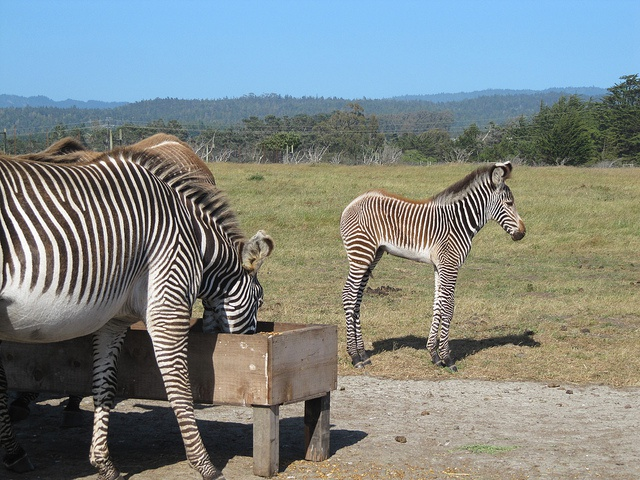Describe the objects in this image and their specific colors. I can see zebra in lightblue, black, gray, lightgray, and darkgray tones and zebra in lightblue, lightgray, darkgray, black, and gray tones in this image. 